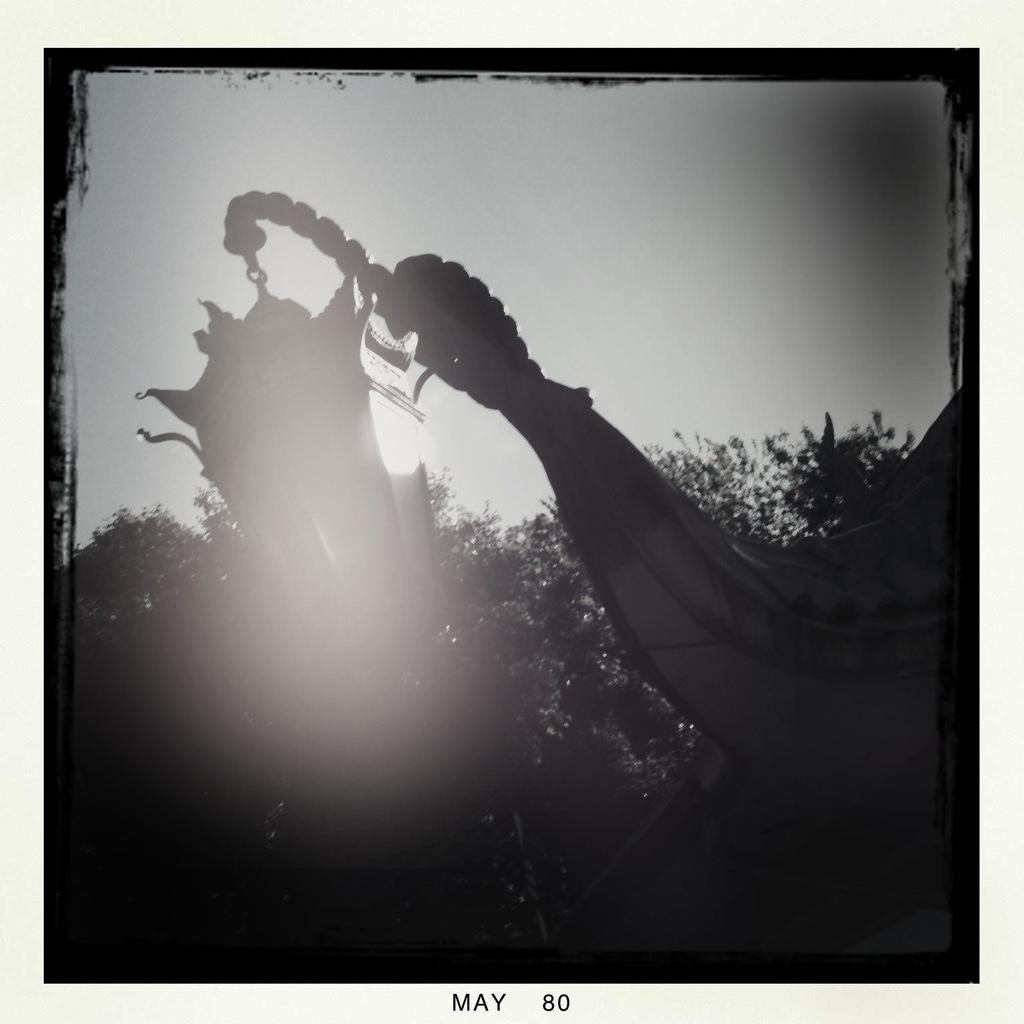Please provide a concise description of this image. In this picture we can see trees and in the background we can see the sky, at the bottom we can see some text. 